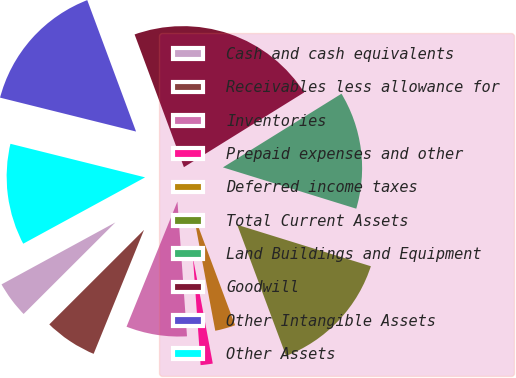Convert chart. <chart><loc_0><loc_0><loc_500><loc_500><pie_chart><fcel>Cash and cash equivalents<fcel>Receivables less allowance for<fcel>Inventories<fcel>Prepaid expenses and other<fcel>Deferred income taxes<fcel>Total Current Assets<fcel>Land Buildings and Equipment<fcel>Goodwill<fcel>Other Intangible Assets<fcel>Other Assets<nl><fcel>4.55%<fcel>6.37%<fcel>7.27%<fcel>1.82%<fcel>2.73%<fcel>14.54%<fcel>13.63%<fcel>21.81%<fcel>15.45%<fcel>11.82%<nl></chart> 